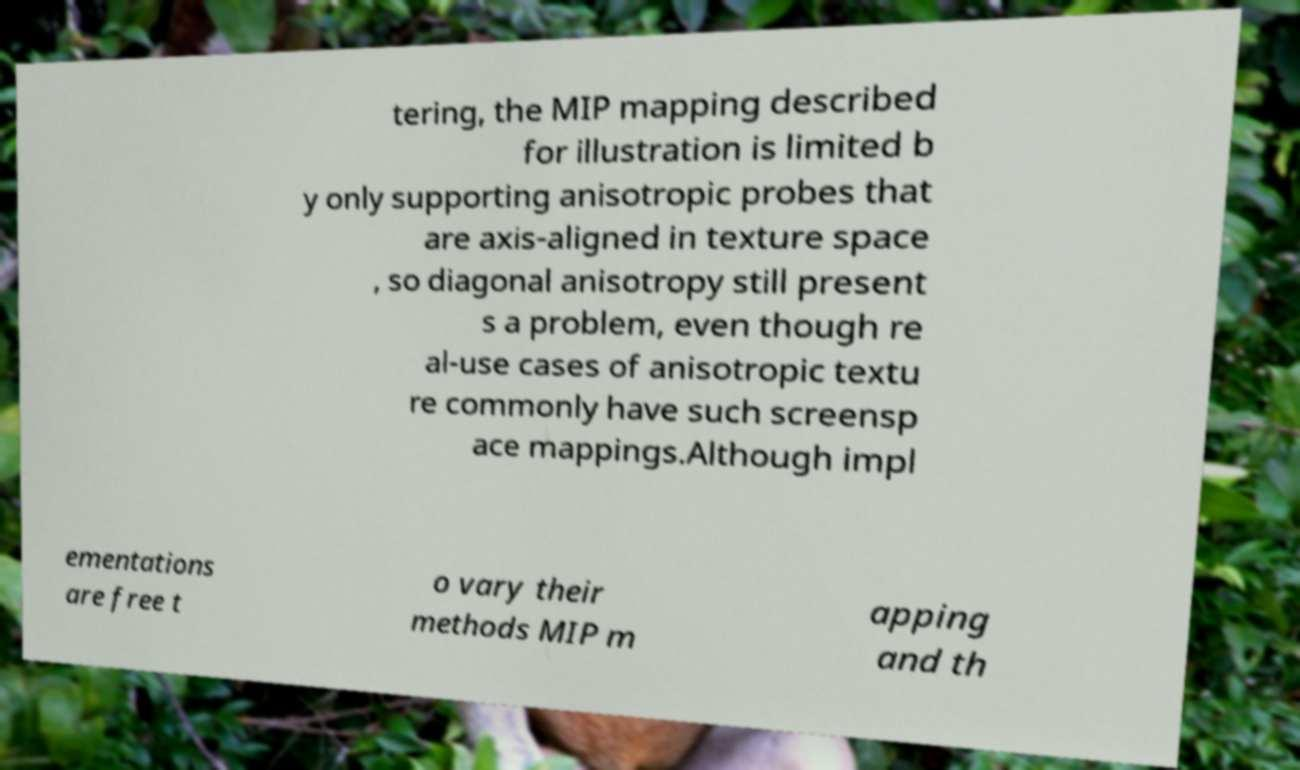I need the written content from this picture converted into text. Can you do that? tering, the MIP mapping described for illustration is limited b y only supporting anisotropic probes that are axis-aligned in texture space , so diagonal anisotropy still present s a problem, even though re al-use cases of anisotropic textu re commonly have such screensp ace mappings.Although impl ementations are free t o vary their methods MIP m apping and th 